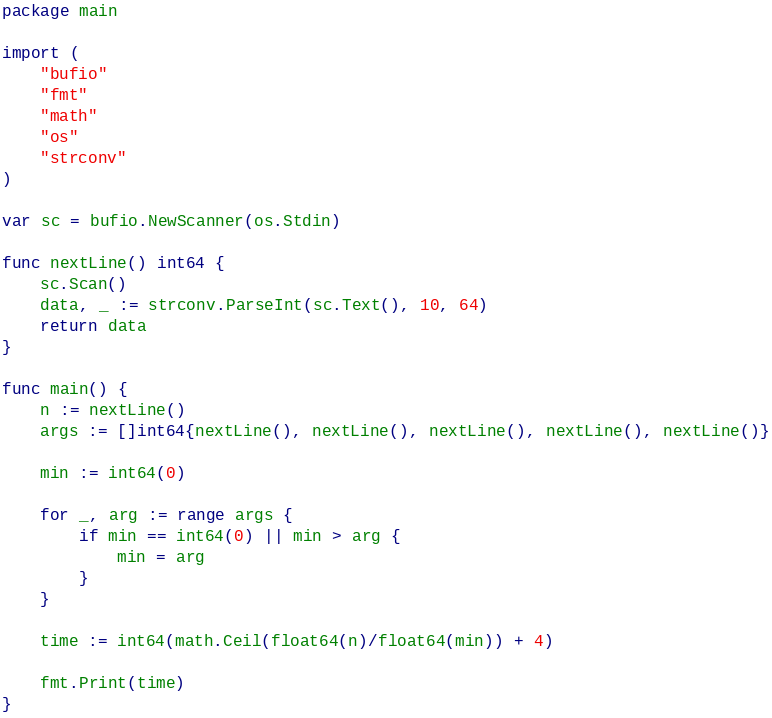<code> <loc_0><loc_0><loc_500><loc_500><_Go_>package main

import (
	"bufio"
	"fmt"
	"math"
	"os"
	"strconv"
)

var sc = bufio.NewScanner(os.Stdin)

func nextLine() int64 {
	sc.Scan()
	data, _ := strconv.ParseInt(sc.Text(), 10, 64)
	return data
}

func main() {
	n := nextLine()
	args := []int64{nextLine(), nextLine(), nextLine(), nextLine(), nextLine()}

	min := int64(0)

	for _, arg := range args {
		if min == int64(0) || min > arg {
			min = arg
		}
	}

	time := int64(math.Ceil(float64(n)/float64(min)) + 4)

	fmt.Print(time)
}</code> 